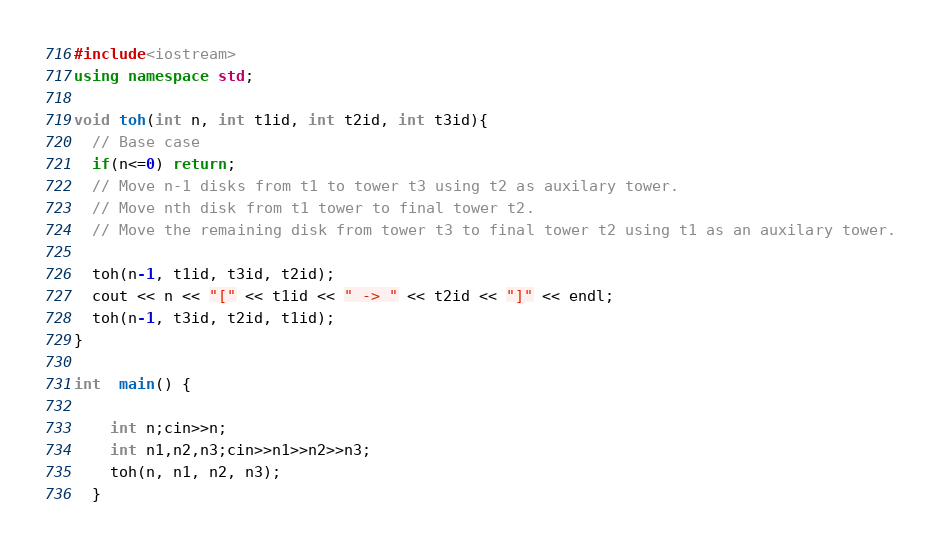<code> <loc_0><loc_0><loc_500><loc_500><_C++_>#include<iostream>
using namespace std;

void toh(int n, int t1id, int t2id, int t3id){
  // Base case
  if(n<=0) return;
  // Move n-1 disks from t1 to tower t3 using t2 as auxilary tower.
  // Move nth disk from t1 tower to final tower t2.
  // Move the remaining disk from tower t3 to final tower t2 using t1 as an auxilary tower.

  toh(n-1, t1id, t3id, t2id);
  cout << n << "[" << t1id << " -> " << t2id << "]" << endl;
  toh(n-1, t3id, t2id, t1id);
}

int  main() {

    int n;cin>>n;
    int n1,n2,n3;cin>>n1>>n2>>n3;
    toh(n, n1, n2, n3);
  }</code> 